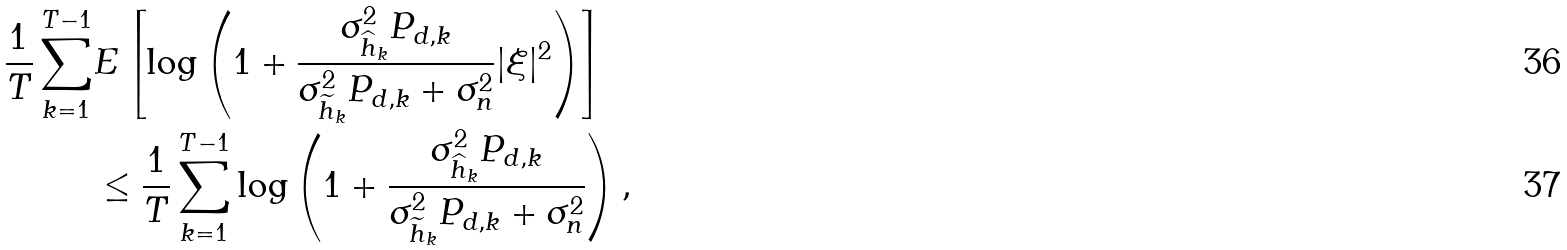Convert formula to latex. <formula><loc_0><loc_0><loc_500><loc_500>\frac { 1 } { T } \sum _ { k = 1 } ^ { T - 1 } & E \left [ \log \left ( 1 + \frac { \sigma _ { \widehat { h } _ { k } } ^ { 2 } P _ { d , k } } { \sigma _ { \widetilde { h } _ { k } } ^ { 2 } P _ { d , k } + \sigma _ { n } ^ { 2 } } | \xi | ^ { 2 } \right ) \right ] \\ & \leq \frac { 1 } { T } \sum _ { k = 1 } ^ { T - 1 } \log \left ( 1 + \frac { \sigma _ { \widehat { h } _ { k } } ^ { 2 } P _ { d , k } } { \sigma _ { \widetilde { h } _ { k } } ^ { 2 } P _ { d , k } + \sigma _ { n } ^ { 2 } } \right ) ,</formula> 